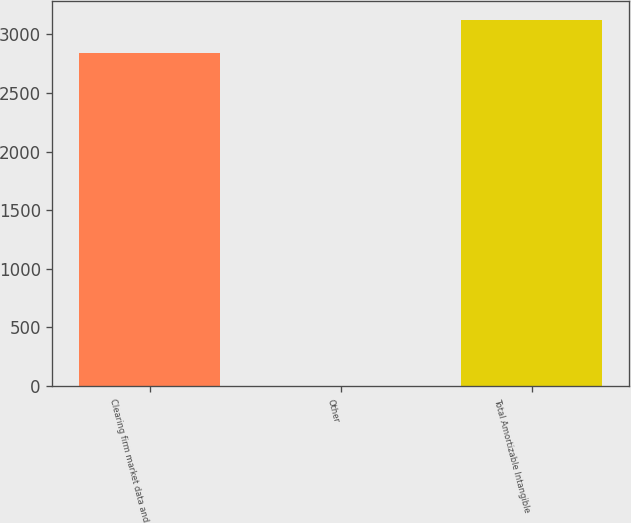<chart> <loc_0><loc_0><loc_500><loc_500><bar_chart><fcel>Clearing firm market data and<fcel>Other<fcel>Total Amortizable Intangible<nl><fcel>2838.8<fcel>2.4<fcel>3125.62<nl></chart> 